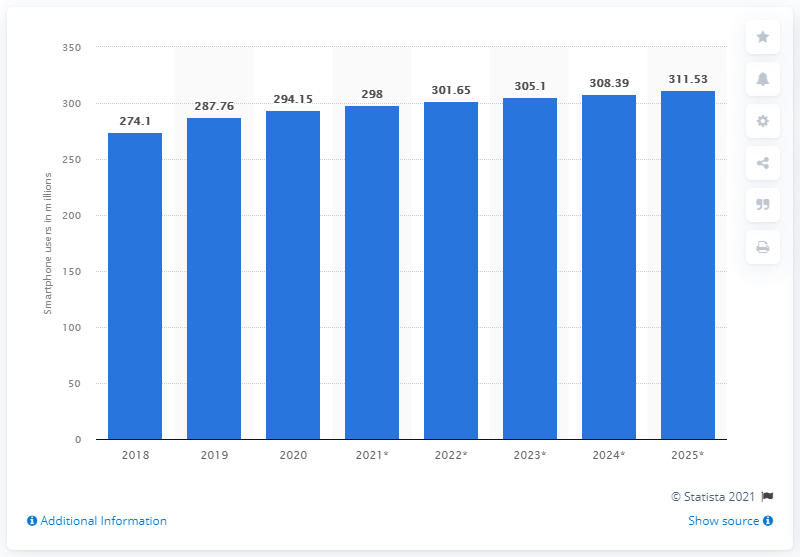Draw attention to some important aspects in this diagram. As of 2020, the estimated number of smartphone users in the United States is 294.15 million. 